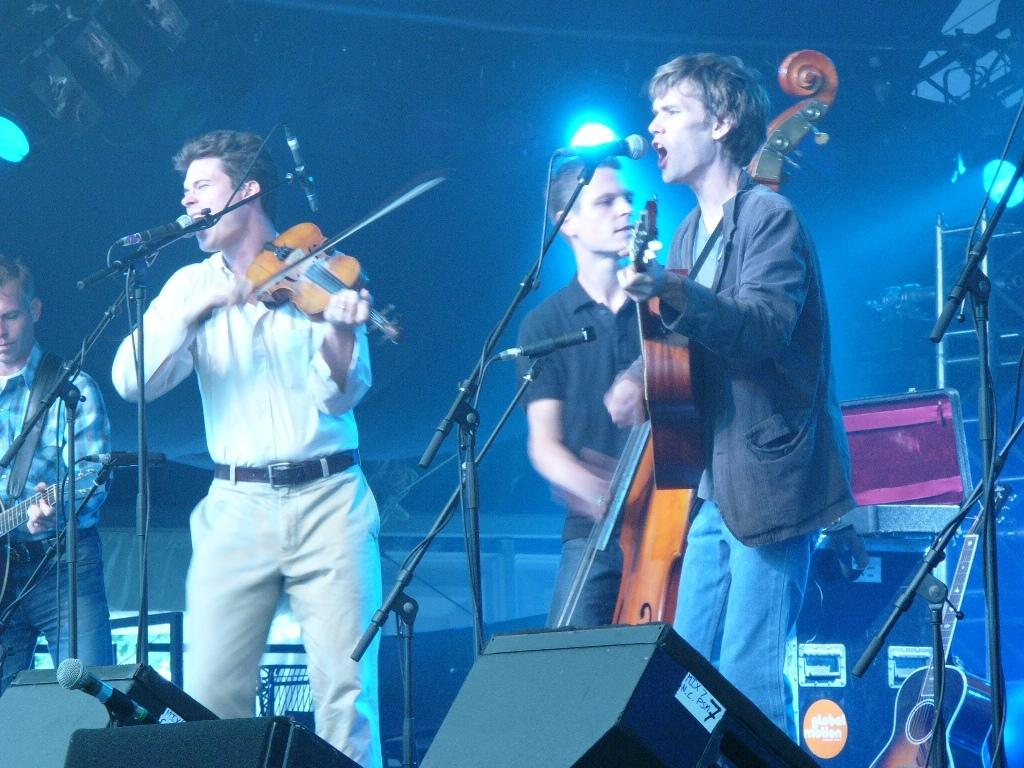What is happening in the image involving the group of people? The people in the image are standing in front of a mic and playing musical instruments. What can be seen behind the group of people? There is a light in the background of the image. What type of basket is being used by the people in the image? There is no basket present in the image; the people are playing musical instruments in front of a mic. 